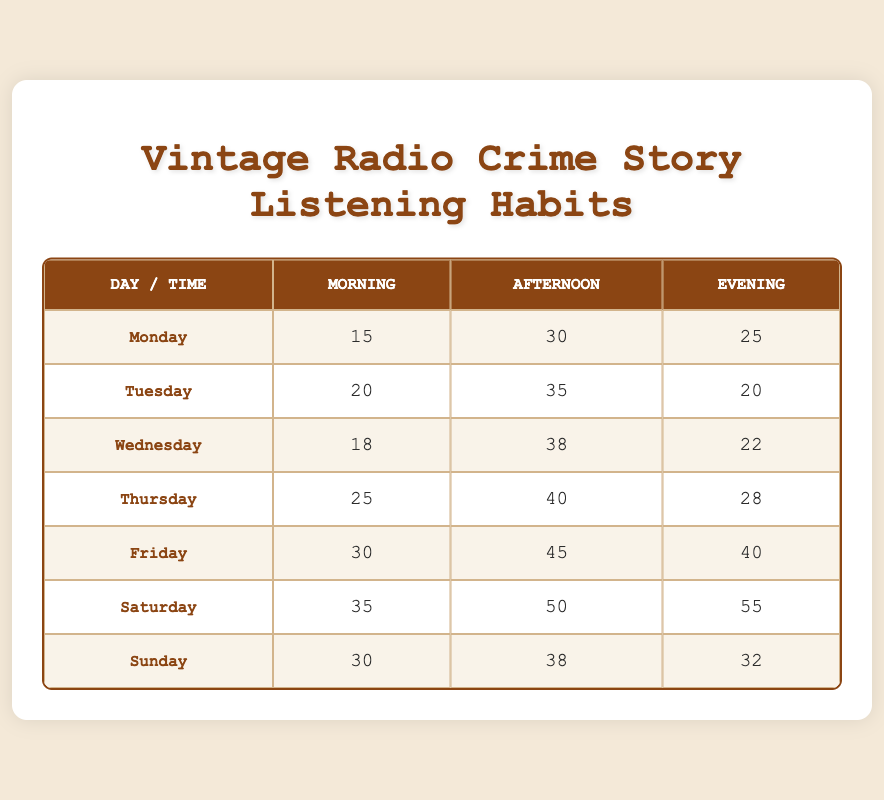What is the highest frequency of listening on Saturday? The table shows that on Saturday, the highest frequency of listening is in the Evening with a count of 55.
Answer: 55 Which day has the least frequency of listening in the Morning? Looking at the Morning column, Monday has the lowest frequency with a count of 15.
Answer: 15 On which day is the Afternoon frequency the highest? The table indicates that Friday has the highest frequency in the Afternoon with a count of 45.
Answer: 45 What is the total frequency of listening for all days combined during the Evening? To find this, we sum the Evening frequencies: 25 (Monday) + 20 (Tuesday) + 22 (Wednesday) + 28 (Thursday) + 40 (Friday) + 55 (Saturday) + 32 (Sunday) = 222.
Answer: 222 Is it true that Thursday has a higher frequency in the Afternoon than Tuesday? Yes, Thursday has an Afternoon frequency of 40, while Tuesday has 35, making the statement true.
Answer: Yes What is the average frequency of listening across all days for the Morning sessions? Total frequency for the Morning sessions is 15 + 20 + 18 + 25 + 30 + 35 + 30 = 173. There are 7 days, so the average is 173 / 7 ≈ 24.71.
Answer: 24.71 Which day has a higher total frequency of listening across all times, Saturday or Friday? For Saturday, the total is 35 (Morning) + 50 (Afternoon) + 55 (Evening) = 140. For Friday, it is 30 (Morning) + 45 (Afternoon) + 40 (Evening) = 115. Thus, Saturday has a higher total frequency.
Answer: Saturday What time of day has the lowest overall frequency of listening across all days? By summing up each time of day: Morning total = 15 + 20 + 18 + 25 + 30 + 35 + 30 = 173, Afternoon total = 30 + 35 + 38 + 40 + 45 + 50 + 38 = 276, Evening total = 25 + 20 + 22 + 28 + 40 + 55 + 32 = 222. Therefore, Morning has the lowest total frequency.
Answer: Morning Which day has an Evening frequency that is less than 30? By inspecting the Evening frequencies, Tuesday (20) and Wednesday (22) both have an Evening frequency less than 30.
Answer: Tuesday, Wednesday 